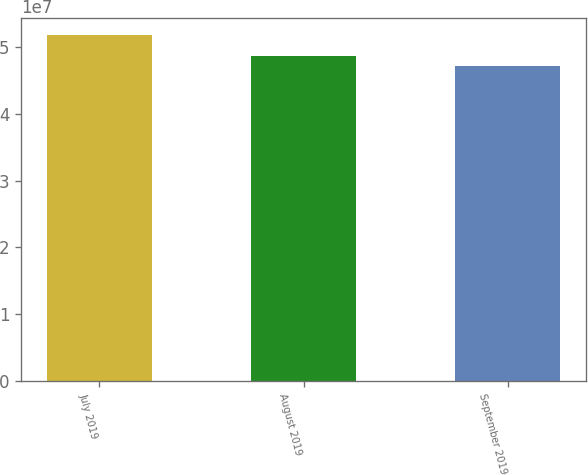<chart> <loc_0><loc_0><loc_500><loc_500><bar_chart><fcel>July 2019<fcel>August 2019<fcel>September 2019<nl><fcel>5.17925e+07<fcel>4.86355e+07<fcel>4.71758e+07<nl></chart> 